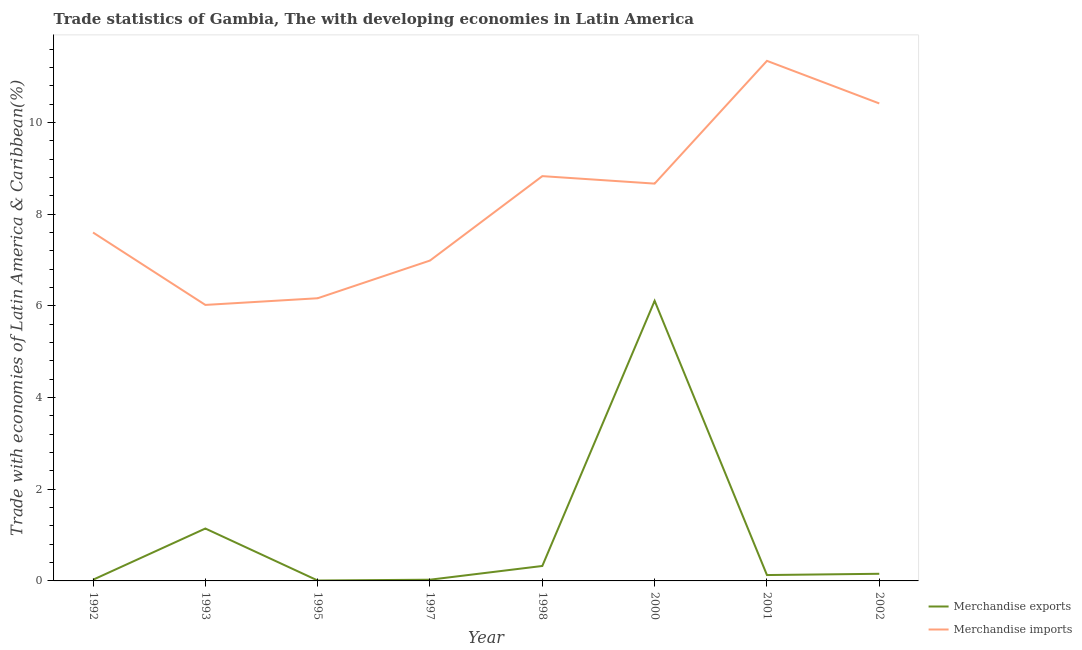How many different coloured lines are there?
Ensure brevity in your answer.  2. Is the number of lines equal to the number of legend labels?
Ensure brevity in your answer.  Yes. What is the merchandise exports in 1998?
Keep it short and to the point. 0.33. Across all years, what is the maximum merchandise imports?
Ensure brevity in your answer.  11.35. Across all years, what is the minimum merchandise exports?
Offer a very short reply. 0.01. In which year was the merchandise exports minimum?
Make the answer very short. 1995. What is the total merchandise exports in the graph?
Your answer should be very brief. 7.93. What is the difference between the merchandise imports in 2001 and that in 2002?
Provide a succinct answer. 0.93. What is the difference between the merchandise exports in 2001 and the merchandise imports in 1995?
Your response must be concise. -6.04. What is the average merchandise imports per year?
Keep it short and to the point. 8.26. In the year 1993, what is the difference between the merchandise imports and merchandise exports?
Your answer should be very brief. 4.88. In how many years, is the merchandise imports greater than 6.8 %?
Your answer should be compact. 6. What is the ratio of the merchandise imports in 1997 to that in 2000?
Offer a very short reply. 0.81. Is the difference between the merchandise imports in 1993 and 1997 greater than the difference between the merchandise exports in 1993 and 1997?
Ensure brevity in your answer.  No. What is the difference between the highest and the second highest merchandise exports?
Make the answer very short. 4.97. What is the difference between the highest and the lowest merchandise imports?
Provide a short and direct response. 5.33. Is the sum of the merchandise exports in 1993 and 2000 greater than the maximum merchandise imports across all years?
Your answer should be very brief. No. How many lines are there?
Provide a short and direct response. 2. What is the difference between two consecutive major ticks on the Y-axis?
Your answer should be compact. 2. Are the values on the major ticks of Y-axis written in scientific E-notation?
Keep it short and to the point. No. Does the graph contain any zero values?
Offer a very short reply. No. Where does the legend appear in the graph?
Provide a succinct answer. Bottom right. How many legend labels are there?
Make the answer very short. 2. How are the legend labels stacked?
Your answer should be very brief. Vertical. What is the title of the graph?
Your answer should be very brief. Trade statistics of Gambia, The with developing economies in Latin America. What is the label or title of the X-axis?
Provide a succinct answer. Year. What is the label or title of the Y-axis?
Give a very brief answer. Trade with economies of Latin America & Caribbean(%). What is the Trade with economies of Latin America & Caribbean(%) in Merchandise exports in 1992?
Offer a terse response. 0.03. What is the Trade with economies of Latin America & Caribbean(%) in Merchandise imports in 1992?
Provide a succinct answer. 7.6. What is the Trade with economies of Latin America & Caribbean(%) in Merchandise exports in 1993?
Give a very brief answer. 1.14. What is the Trade with economies of Latin America & Caribbean(%) in Merchandise imports in 1993?
Keep it short and to the point. 6.02. What is the Trade with economies of Latin America & Caribbean(%) of Merchandise exports in 1995?
Your answer should be very brief. 0.01. What is the Trade with economies of Latin America & Caribbean(%) of Merchandise imports in 1995?
Ensure brevity in your answer.  6.17. What is the Trade with economies of Latin America & Caribbean(%) of Merchandise exports in 1997?
Keep it short and to the point. 0.03. What is the Trade with economies of Latin America & Caribbean(%) in Merchandise imports in 1997?
Provide a short and direct response. 6.99. What is the Trade with economies of Latin America & Caribbean(%) in Merchandise exports in 1998?
Offer a terse response. 0.33. What is the Trade with economies of Latin America & Caribbean(%) of Merchandise imports in 1998?
Offer a terse response. 8.83. What is the Trade with economies of Latin America & Caribbean(%) of Merchandise exports in 2000?
Your answer should be very brief. 6.11. What is the Trade with economies of Latin America & Caribbean(%) of Merchandise imports in 2000?
Your answer should be compact. 8.67. What is the Trade with economies of Latin America & Caribbean(%) in Merchandise exports in 2001?
Give a very brief answer. 0.13. What is the Trade with economies of Latin America & Caribbean(%) of Merchandise imports in 2001?
Keep it short and to the point. 11.35. What is the Trade with economies of Latin America & Caribbean(%) of Merchandise exports in 2002?
Give a very brief answer. 0.16. What is the Trade with economies of Latin America & Caribbean(%) of Merchandise imports in 2002?
Provide a short and direct response. 10.42. Across all years, what is the maximum Trade with economies of Latin America & Caribbean(%) of Merchandise exports?
Offer a terse response. 6.11. Across all years, what is the maximum Trade with economies of Latin America & Caribbean(%) of Merchandise imports?
Your answer should be compact. 11.35. Across all years, what is the minimum Trade with economies of Latin America & Caribbean(%) in Merchandise exports?
Offer a terse response. 0.01. Across all years, what is the minimum Trade with economies of Latin America & Caribbean(%) in Merchandise imports?
Your answer should be compact. 6.02. What is the total Trade with economies of Latin America & Caribbean(%) in Merchandise exports in the graph?
Your answer should be very brief. 7.93. What is the total Trade with economies of Latin America & Caribbean(%) of Merchandise imports in the graph?
Provide a succinct answer. 66.05. What is the difference between the Trade with economies of Latin America & Caribbean(%) in Merchandise exports in 1992 and that in 1993?
Offer a very short reply. -1.12. What is the difference between the Trade with economies of Latin America & Caribbean(%) in Merchandise imports in 1992 and that in 1993?
Make the answer very short. 1.58. What is the difference between the Trade with economies of Latin America & Caribbean(%) of Merchandise exports in 1992 and that in 1995?
Your answer should be very brief. 0.02. What is the difference between the Trade with economies of Latin America & Caribbean(%) in Merchandise imports in 1992 and that in 1995?
Ensure brevity in your answer.  1.43. What is the difference between the Trade with economies of Latin America & Caribbean(%) in Merchandise exports in 1992 and that in 1997?
Offer a terse response. -0. What is the difference between the Trade with economies of Latin America & Caribbean(%) in Merchandise imports in 1992 and that in 1997?
Your answer should be very brief. 0.61. What is the difference between the Trade with economies of Latin America & Caribbean(%) of Merchandise exports in 1992 and that in 1998?
Give a very brief answer. -0.3. What is the difference between the Trade with economies of Latin America & Caribbean(%) of Merchandise imports in 1992 and that in 1998?
Ensure brevity in your answer.  -1.23. What is the difference between the Trade with economies of Latin America & Caribbean(%) in Merchandise exports in 1992 and that in 2000?
Offer a terse response. -6.09. What is the difference between the Trade with economies of Latin America & Caribbean(%) in Merchandise imports in 1992 and that in 2000?
Your answer should be very brief. -1.07. What is the difference between the Trade with economies of Latin America & Caribbean(%) of Merchandise exports in 1992 and that in 2001?
Your answer should be compact. -0.1. What is the difference between the Trade with economies of Latin America & Caribbean(%) in Merchandise imports in 1992 and that in 2001?
Make the answer very short. -3.74. What is the difference between the Trade with economies of Latin America & Caribbean(%) of Merchandise exports in 1992 and that in 2002?
Offer a terse response. -0.13. What is the difference between the Trade with economies of Latin America & Caribbean(%) in Merchandise imports in 1992 and that in 2002?
Your response must be concise. -2.82. What is the difference between the Trade with economies of Latin America & Caribbean(%) of Merchandise exports in 1993 and that in 1995?
Make the answer very short. 1.13. What is the difference between the Trade with economies of Latin America & Caribbean(%) in Merchandise imports in 1993 and that in 1995?
Your answer should be compact. -0.15. What is the difference between the Trade with economies of Latin America & Caribbean(%) in Merchandise exports in 1993 and that in 1997?
Your answer should be very brief. 1.12. What is the difference between the Trade with economies of Latin America & Caribbean(%) in Merchandise imports in 1993 and that in 1997?
Your answer should be very brief. -0.97. What is the difference between the Trade with economies of Latin America & Caribbean(%) of Merchandise exports in 1993 and that in 1998?
Ensure brevity in your answer.  0.82. What is the difference between the Trade with economies of Latin America & Caribbean(%) in Merchandise imports in 1993 and that in 1998?
Keep it short and to the point. -2.81. What is the difference between the Trade with economies of Latin America & Caribbean(%) in Merchandise exports in 1993 and that in 2000?
Ensure brevity in your answer.  -4.97. What is the difference between the Trade with economies of Latin America & Caribbean(%) in Merchandise imports in 1993 and that in 2000?
Ensure brevity in your answer.  -2.65. What is the difference between the Trade with economies of Latin America & Caribbean(%) in Merchandise exports in 1993 and that in 2001?
Your answer should be compact. 1.02. What is the difference between the Trade with economies of Latin America & Caribbean(%) in Merchandise imports in 1993 and that in 2001?
Give a very brief answer. -5.33. What is the difference between the Trade with economies of Latin America & Caribbean(%) of Merchandise exports in 1993 and that in 2002?
Give a very brief answer. 0.99. What is the difference between the Trade with economies of Latin America & Caribbean(%) of Merchandise imports in 1993 and that in 2002?
Keep it short and to the point. -4.4. What is the difference between the Trade with economies of Latin America & Caribbean(%) of Merchandise exports in 1995 and that in 1997?
Your response must be concise. -0.02. What is the difference between the Trade with economies of Latin America & Caribbean(%) of Merchandise imports in 1995 and that in 1997?
Your answer should be very brief. -0.82. What is the difference between the Trade with economies of Latin America & Caribbean(%) of Merchandise exports in 1995 and that in 1998?
Make the answer very short. -0.32. What is the difference between the Trade with economies of Latin America & Caribbean(%) of Merchandise imports in 1995 and that in 1998?
Offer a very short reply. -2.66. What is the difference between the Trade with economies of Latin America & Caribbean(%) in Merchandise exports in 1995 and that in 2000?
Your answer should be very brief. -6.1. What is the difference between the Trade with economies of Latin America & Caribbean(%) of Merchandise imports in 1995 and that in 2000?
Offer a very short reply. -2.5. What is the difference between the Trade with economies of Latin America & Caribbean(%) in Merchandise exports in 1995 and that in 2001?
Offer a very short reply. -0.12. What is the difference between the Trade with economies of Latin America & Caribbean(%) in Merchandise imports in 1995 and that in 2001?
Make the answer very short. -5.18. What is the difference between the Trade with economies of Latin America & Caribbean(%) of Merchandise exports in 1995 and that in 2002?
Offer a very short reply. -0.15. What is the difference between the Trade with economies of Latin America & Caribbean(%) in Merchandise imports in 1995 and that in 2002?
Offer a terse response. -4.25. What is the difference between the Trade with economies of Latin America & Caribbean(%) in Merchandise exports in 1997 and that in 1998?
Your answer should be very brief. -0.3. What is the difference between the Trade with economies of Latin America & Caribbean(%) of Merchandise imports in 1997 and that in 1998?
Offer a very short reply. -1.84. What is the difference between the Trade with economies of Latin America & Caribbean(%) of Merchandise exports in 1997 and that in 2000?
Ensure brevity in your answer.  -6.08. What is the difference between the Trade with economies of Latin America & Caribbean(%) in Merchandise imports in 1997 and that in 2000?
Make the answer very short. -1.68. What is the difference between the Trade with economies of Latin America & Caribbean(%) in Merchandise exports in 1997 and that in 2001?
Offer a terse response. -0.1. What is the difference between the Trade with economies of Latin America & Caribbean(%) in Merchandise imports in 1997 and that in 2001?
Provide a short and direct response. -4.36. What is the difference between the Trade with economies of Latin America & Caribbean(%) of Merchandise exports in 1997 and that in 2002?
Your response must be concise. -0.13. What is the difference between the Trade with economies of Latin America & Caribbean(%) of Merchandise imports in 1997 and that in 2002?
Keep it short and to the point. -3.43. What is the difference between the Trade with economies of Latin America & Caribbean(%) of Merchandise exports in 1998 and that in 2000?
Your response must be concise. -5.78. What is the difference between the Trade with economies of Latin America & Caribbean(%) of Merchandise imports in 1998 and that in 2000?
Your response must be concise. 0.16. What is the difference between the Trade with economies of Latin America & Caribbean(%) of Merchandise exports in 1998 and that in 2001?
Offer a terse response. 0.2. What is the difference between the Trade with economies of Latin America & Caribbean(%) of Merchandise imports in 1998 and that in 2001?
Keep it short and to the point. -2.52. What is the difference between the Trade with economies of Latin America & Caribbean(%) in Merchandise exports in 1998 and that in 2002?
Give a very brief answer. 0.17. What is the difference between the Trade with economies of Latin America & Caribbean(%) of Merchandise imports in 1998 and that in 2002?
Provide a succinct answer. -1.59. What is the difference between the Trade with economies of Latin America & Caribbean(%) in Merchandise exports in 2000 and that in 2001?
Keep it short and to the point. 5.98. What is the difference between the Trade with economies of Latin America & Caribbean(%) in Merchandise imports in 2000 and that in 2001?
Provide a short and direct response. -2.68. What is the difference between the Trade with economies of Latin America & Caribbean(%) of Merchandise exports in 2000 and that in 2002?
Offer a terse response. 5.96. What is the difference between the Trade with economies of Latin America & Caribbean(%) of Merchandise imports in 2000 and that in 2002?
Make the answer very short. -1.75. What is the difference between the Trade with economies of Latin America & Caribbean(%) in Merchandise exports in 2001 and that in 2002?
Provide a succinct answer. -0.03. What is the difference between the Trade with economies of Latin America & Caribbean(%) in Merchandise imports in 2001 and that in 2002?
Make the answer very short. 0.93. What is the difference between the Trade with economies of Latin America & Caribbean(%) of Merchandise exports in 1992 and the Trade with economies of Latin America & Caribbean(%) of Merchandise imports in 1993?
Offer a terse response. -6. What is the difference between the Trade with economies of Latin America & Caribbean(%) of Merchandise exports in 1992 and the Trade with economies of Latin America & Caribbean(%) of Merchandise imports in 1995?
Offer a terse response. -6.14. What is the difference between the Trade with economies of Latin America & Caribbean(%) of Merchandise exports in 1992 and the Trade with economies of Latin America & Caribbean(%) of Merchandise imports in 1997?
Your answer should be compact. -6.96. What is the difference between the Trade with economies of Latin America & Caribbean(%) in Merchandise exports in 1992 and the Trade with economies of Latin America & Caribbean(%) in Merchandise imports in 1998?
Your answer should be very brief. -8.81. What is the difference between the Trade with economies of Latin America & Caribbean(%) in Merchandise exports in 1992 and the Trade with economies of Latin America & Caribbean(%) in Merchandise imports in 2000?
Offer a very short reply. -8.64. What is the difference between the Trade with economies of Latin America & Caribbean(%) of Merchandise exports in 1992 and the Trade with economies of Latin America & Caribbean(%) of Merchandise imports in 2001?
Ensure brevity in your answer.  -11.32. What is the difference between the Trade with economies of Latin America & Caribbean(%) of Merchandise exports in 1992 and the Trade with economies of Latin America & Caribbean(%) of Merchandise imports in 2002?
Your answer should be very brief. -10.39. What is the difference between the Trade with economies of Latin America & Caribbean(%) in Merchandise exports in 1993 and the Trade with economies of Latin America & Caribbean(%) in Merchandise imports in 1995?
Provide a succinct answer. -5.02. What is the difference between the Trade with economies of Latin America & Caribbean(%) in Merchandise exports in 1993 and the Trade with economies of Latin America & Caribbean(%) in Merchandise imports in 1997?
Ensure brevity in your answer.  -5.85. What is the difference between the Trade with economies of Latin America & Caribbean(%) of Merchandise exports in 1993 and the Trade with economies of Latin America & Caribbean(%) of Merchandise imports in 1998?
Provide a short and direct response. -7.69. What is the difference between the Trade with economies of Latin America & Caribbean(%) of Merchandise exports in 1993 and the Trade with economies of Latin America & Caribbean(%) of Merchandise imports in 2000?
Keep it short and to the point. -7.53. What is the difference between the Trade with economies of Latin America & Caribbean(%) in Merchandise exports in 1993 and the Trade with economies of Latin America & Caribbean(%) in Merchandise imports in 2001?
Make the answer very short. -10.2. What is the difference between the Trade with economies of Latin America & Caribbean(%) of Merchandise exports in 1993 and the Trade with economies of Latin America & Caribbean(%) of Merchandise imports in 2002?
Make the answer very short. -9.27. What is the difference between the Trade with economies of Latin America & Caribbean(%) of Merchandise exports in 1995 and the Trade with economies of Latin America & Caribbean(%) of Merchandise imports in 1997?
Your answer should be very brief. -6.98. What is the difference between the Trade with economies of Latin America & Caribbean(%) in Merchandise exports in 1995 and the Trade with economies of Latin America & Caribbean(%) in Merchandise imports in 1998?
Make the answer very short. -8.82. What is the difference between the Trade with economies of Latin America & Caribbean(%) of Merchandise exports in 1995 and the Trade with economies of Latin America & Caribbean(%) of Merchandise imports in 2000?
Offer a very short reply. -8.66. What is the difference between the Trade with economies of Latin America & Caribbean(%) of Merchandise exports in 1995 and the Trade with economies of Latin America & Caribbean(%) of Merchandise imports in 2001?
Give a very brief answer. -11.34. What is the difference between the Trade with economies of Latin America & Caribbean(%) of Merchandise exports in 1995 and the Trade with economies of Latin America & Caribbean(%) of Merchandise imports in 2002?
Keep it short and to the point. -10.41. What is the difference between the Trade with economies of Latin America & Caribbean(%) of Merchandise exports in 1997 and the Trade with economies of Latin America & Caribbean(%) of Merchandise imports in 1998?
Offer a terse response. -8.81. What is the difference between the Trade with economies of Latin America & Caribbean(%) in Merchandise exports in 1997 and the Trade with economies of Latin America & Caribbean(%) in Merchandise imports in 2000?
Your answer should be very brief. -8.64. What is the difference between the Trade with economies of Latin America & Caribbean(%) of Merchandise exports in 1997 and the Trade with economies of Latin America & Caribbean(%) of Merchandise imports in 2001?
Your answer should be very brief. -11.32. What is the difference between the Trade with economies of Latin America & Caribbean(%) of Merchandise exports in 1997 and the Trade with economies of Latin America & Caribbean(%) of Merchandise imports in 2002?
Your answer should be very brief. -10.39. What is the difference between the Trade with economies of Latin America & Caribbean(%) of Merchandise exports in 1998 and the Trade with economies of Latin America & Caribbean(%) of Merchandise imports in 2000?
Keep it short and to the point. -8.34. What is the difference between the Trade with economies of Latin America & Caribbean(%) in Merchandise exports in 1998 and the Trade with economies of Latin America & Caribbean(%) in Merchandise imports in 2001?
Keep it short and to the point. -11.02. What is the difference between the Trade with economies of Latin America & Caribbean(%) in Merchandise exports in 1998 and the Trade with economies of Latin America & Caribbean(%) in Merchandise imports in 2002?
Ensure brevity in your answer.  -10.09. What is the difference between the Trade with economies of Latin America & Caribbean(%) of Merchandise exports in 2000 and the Trade with economies of Latin America & Caribbean(%) of Merchandise imports in 2001?
Ensure brevity in your answer.  -5.24. What is the difference between the Trade with economies of Latin America & Caribbean(%) in Merchandise exports in 2000 and the Trade with economies of Latin America & Caribbean(%) in Merchandise imports in 2002?
Offer a very short reply. -4.31. What is the difference between the Trade with economies of Latin America & Caribbean(%) of Merchandise exports in 2001 and the Trade with economies of Latin America & Caribbean(%) of Merchandise imports in 2002?
Your answer should be very brief. -10.29. What is the average Trade with economies of Latin America & Caribbean(%) of Merchandise exports per year?
Your answer should be very brief. 0.99. What is the average Trade with economies of Latin America & Caribbean(%) in Merchandise imports per year?
Keep it short and to the point. 8.26. In the year 1992, what is the difference between the Trade with economies of Latin America & Caribbean(%) in Merchandise exports and Trade with economies of Latin America & Caribbean(%) in Merchandise imports?
Provide a succinct answer. -7.58. In the year 1993, what is the difference between the Trade with economies of Latin America & Caribbean(%) in Merchandise exports and Trade with economies of Latin America & Caribbean(%) in Merchandise imports?
Your response must be concise. -4.88. In the year 1995, what is the difference between the Trade with economies of Latin America & Caribbean(%) of Merchandise exports and Trade with economies of Latin America & Caribbean(%) of Merchandise imports?
Offer a terse response. -6.16. In the year 1997, what is the difference between the Trade with economies of Latin America & Caribbean(%) of Merchandise exports and Trade with economies of Latin America & Caribbean(%) of Merchandise imports?
Ensure brevity in your answer.  -6.96. In the year 1998, what is the difference between the Trade with economies of Latin America & Caribbean(%) of Merchandise exports and Trade with economies of Latin America & Caribbean(%) of Merchandise imports?
Make the answer very short. -8.51. In the year 2000, what is the difference between the Trade with economies of Latin America & Caribbean(%) of Merchandise exports and Trade with economies of Latin America & Caribbean(%) of Merchandise imports?
Your answer should be compact. -2.56. In the year 2001, what is the difference between the Trade with economies of Latin America & Caribbean(%) in Merchandise exports and Trade with economies of Latin America & Caribbean(%) in Merchandise imports?
Provide a succinct answer. -11.22. In the year 2002, what is the difference between the Trade with economies of Latin America & Caribbean(%) of Merchandise exports and Trade with economies of Latin America & Caribbean(%) of Merchandise imports?
Provide a succinct answer. -10.26. What is the ratio of the Trade with economies of Latin America & Caribbean(%) in Merchandise exports in 1992 to that in 1993?
Your answer should be very brief. 0.02. What is the ratio of the Trade with economies of Latin America & Caribbean(%) of Merchandise imports in 1992 to that in 1993?
Make the answer very short. 1.26. What is the ratio of the Trade with economies of Latin America & Caribbean(%) in Merchandise exports in 1992 to that in 1995?
Your answer should be compact. 2.85. What is the ratio of the Trade with economies of Latin America & Caribbean(%) of Merchandise imports in 1992 to that in 1995?
Make the answer very short. 1.23. What is the ratio of the Trade with economies of Latin America & Caribbean(%) in Merchandise exports in 1992 to that in 1997?
Your response must be concise. 0.97. What is the ratio of the Trade with economies of Latin America & Caribbean(%) in Merchandise imports in 1992 to that in 1997?
Keep it short and to the point. 1.09. What is the ratio of the Trade with economies of Latin America & Caribbean(%) in Merchandise exports in 1992 to that in 1998?
Your response must be concise. 0.08. What is the ratio of the Trade with economies of Latin America & Caribbean(%) in Merchandise imports in 1992 to that in 1998?
Give a very brief answer. 0.86. What is the ratio of the Trade with economies of Latin America & Caribbean(%) in Merchandise exports in 1992 to that in 2000?
Offer a terse response. 0. What is the ratio of the Trade with economies of Latin America & Caribbean(%) of Merchandise imports in 1992 to that in 2000?
Ensure brevity in your answer.  0.88. What is the ratio of the Trade with economies of Latin America & Caribbean(%) of Merchandise exports in 1992 to that in 2001?
Offer a very short reply. 0.2. What is the ratio of the Trade with economies of Latin America & Caribbean(%) in Merchandise imports in 1992 to that in 2001?
Your answer should be very brief. 0.67. What is the ratio of the Trade with economies of Latin America & Caribbean(%) in Merchandise exports in 1992 to that in 2002?
Your answer should be compact. 0.17. What is the ratio of the Trade with economies of Latin America & Caribbean(%) of Merchandise imports in 1992 to that in 2002?
Offer a terse response. 0.73. What is the ratio of the Trade with economies of Latin America & Caribbean(%) in Merchandise exports in 1993 to that in 1995?
Keep it short and to the point. 126.25. What is the ratio of the Trade with economies of Latin America & Caribbean(%) of Merchandise imports in 1993 to that in 1995?
Ensure brevity in your answer.  0.98. What is the ratio of the Trade with economies of Latin America & Caribbean(%) of Merchandise exports in 1993 to that in 1997?
Provide a short and direct response. 42.82. What is the ratio of the Trade with economies of Latin America & Caribbean(%) of Merchandise imports in 1993 to that in 1997?
Offer a terse response. 0.86. What is the ratio of the Trade with economies of Latin America & Caribbean(%) of Merchandise exports in 1993 to that in 1998?
Make the answer very short. 3.51. What is the ratio of the Trade with economies of Latin America & Caribbean(%) in Merchandise imports in 1993 to that in 1998?
Your answer should be compact. 0.68. What is the ratio of the Trade with economies of Latin America & Caribbean(%) in Merchandise exports in 1993 to that in 2000?
Your answer should be very brief. 0.19. What is the ratio of the Trade with economies of Latin America & Caribbean(%) of Merchandise imports in 1993 to that in 2000?
Offer a very short reply. 0.69. What is the ratio of the Trade with economies of Latin America & Caribbean(%) in Merchandise exports in 1993 to that in 2001?
Your answer should be very brief. 8.93. What is the ratio of the Trade with economies of Latin America & Caribbean(%) in Merchandise imports in 1993 to that in 2001?
Offer a very short reply. 0.53. What is the ratio of the Trade with economies of Latin America & Caribbean(%) in Merchandise exports in 1993 to that in 2002?
Your answer should be very brief. 7.34. What is the ratio of the Trade with economies of Latin America & Caribbean(%) of Merchandise imports in 1993 to that in 2002?
Keep it short and to the point. 0.58. What is the ratio of the Trade with economies of Latin America & Caribbean(%) of Merchandise exports in 1995 to that in 1997?
Make the answer very short. 0.34. What is the ratio of the Trade with economies of Latin America & Caribbean(%) in Merchandise imports in 1995 to that in 1997?
Keep it short and to the point. 0.88. What is the ratio of the Trade with economies of Latin America & Caribbean(%) of Merchandise exports in 1995 to that in 1998?
Your response must be concise. 0.03. What is the ratio of the Trade with economies of Latin America & Caribbean(%) in Merchandise imports in 1995 to that in 1998?
Make the answer very short. 0.7. What is the ratio of the Trade with economies of Latin America & Caribbean(%) of Merchandise exports in 1995 to that in 2000?
Offer a very short reply. 0. What is the ratio of the Trade with economies of Latin America & Caribbean(%) in Merchandise imports in 1995 to that in 2000?
Your answer should be very brief. 0.71. What is the ratio of the Trade with economies of Latin America & Caribbean(%) in Merchandise exports in 1995 to that in 2001?
Ensure brevity in your answer.  0.07. What is the ratio of the Trade with economies of Latin America & Caribbean(%) in Merchandise imports in 1995 to that in 2001?
Your answer should be very brief. 0.54. What is the ratio of the Trade with economies of Latin America & Caribbean(%) of Merchandise exports in 1995 to that in 2002?
Your response must be concise. 0.06. What is the ratio of the Trade with economies of Latin America & Caribbean(%) of Merchandise imports in 1995 to that in 2002?
Your answer should be compact. 0.59. What is the ratio of the Trade with economies of Latin America & Caribbean(%) of Merchandise exports in 1997 to that in 1998?
Provide a succinct answer. 0.08. What is the ratio of the Trade with economies of Latin America & Caribbean(%) of Merchandise imports in 1997 to that in 1998?
Ensure brevity in your answer.  0.79. What is the ratio of the Trade with economies of Latin America & Caribbean(%) in Merchandise exports in 1997 to that in 2000?
Offer a terse response. 0. What is the ratio of the Trade with economies of Latin America & Caribbean(%) of Merchandise imports in 1997 to that in 2000?
Provide a succinct answer. 0.81. What is the ratio of the Trade with economies of Latin America & Caribbean(%) of Merchandise exports in 1997 to that in 2001?
Offer a very short reply. 0.21. What is the ratio of the Trade with economies of Latin America & Caribbean(%) in Merchandise imports in 1997 to that in 2001?
Give a very brief answer. 0.62. What is the ratio of the Trade with economies of Latin America & Caribbean(%) of Merchandise exports in 1997 to that in 2002?
Ensure brevity in your answer.  0.17. What is the ratio of the Trade with economies of Latin America & Caribbean(%) in Merchandise imports in 1997 to that in 2002?
Your response must be concise. 0.67. What is the ratio of the Trade with economies of Latin America & Caribbean(%) in Merchandise exports in 1998 to that in 2000?
Offer a terse response. 0.05. What is the ratio of the Trade with economies of Latin America & Caribbean(%) in Merchandise imports in 1998 to that in 2000?
Your answer should be compact. 1.02. What is the ratio of the Trade with economies of Latin America & Caribbean(%) in Merchandise exports in 1998 to that in 2001?
Keep it short and to the point. 2.55. What is the ratio of the Trade with economies of Latin America & Caribbean(%) of Merchandise imports in 1998 to that in 2001?
Keep it short and to the point. 0.78. What is the ratio of the Trade with economies of Latin America & Caribbean(%) of Merchandise exports in 1998 to that in 2002?
Make the answer very short. 2.09. What is the ratio of the Trade with economies of Latin America & Caribbean(%) in Merchandise imports in 1998 to that in 2002?
Make the answer very short. 0.85. What is the ratio of the Trade with economies of Latin America & Caribbean(%) in Merchandise exports in 2000 to that in 2001?
Ensure brevity in your answer.  47.73. What is the ratio of the Trade with economies of Latin America & Caribbean(%) in Merchandise imports in 2000 to that in 2001?
Your response must be concise. 0.76. What is the ratio of the Trade with economies of Latin America & Caribbean(%) in Merchandise exports in 2000 to that in 2002?
Provide a short and direct response. 39.24. What is the ratio of the Trade with economies of Latin America & Caribbean(%) of Merchandise imports in 2000 to that in 2002?
Provide a succinct answer. 0.83. What is the ratio of the Trade with economies of Latin America & Caribbean(%) of Merchandise exports in 2001 to that in 2002?
Ensure brevity in your answer.  0.82. What is the ratio of the Trade with economies of Latin America & Caribbean(%) in Merchandise imports in 2001 to that in 2002?
Give a very brief answer. 1.09. What is the difference between the highest and the second highest Trade with economies of Latin America & Caribbean(%) of Merchandise exports?
Make the answer very short. 4.97. What is the difference between the highest and the second highest Trade with economies of Latin America & Caribbean(%) in Merchandise imports?
Make the answer very short. 0.93. What is the difference between the highest and the lowest Trade with economies of Latin America & Caribbean(%) of Merchandise exports?
Give a very brief answer. 6.1. What is the difference between the highest and the lowest Trade with economies of Latin America & Caribbean(%) of Merchandise imports?
Give a very brief answer. 5.33. 